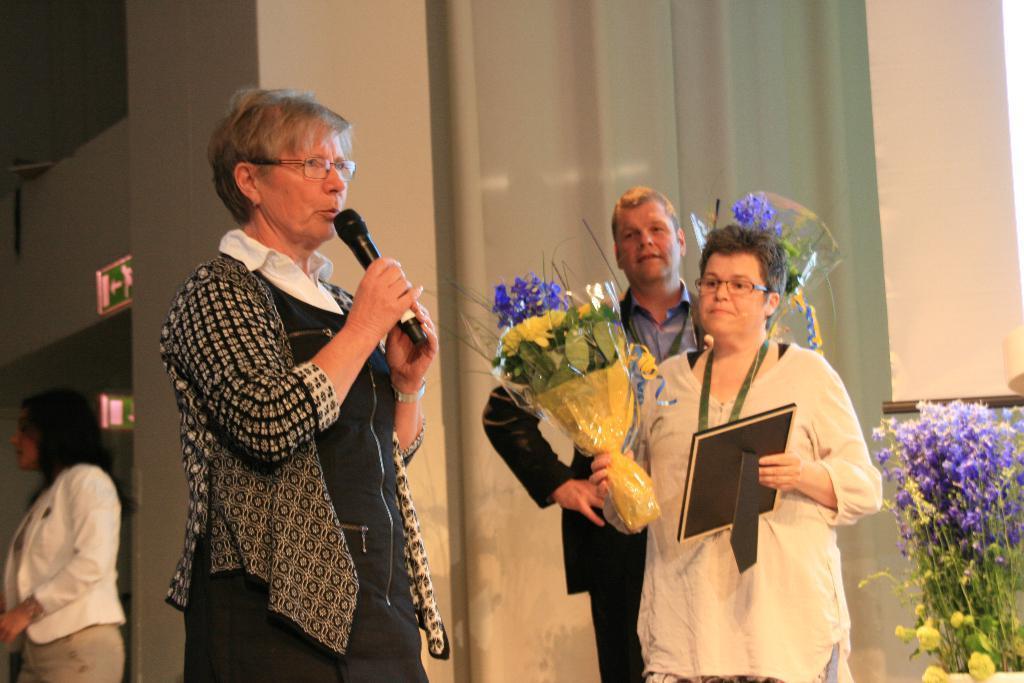Describe this image in one or two sentences. There are four people. They are standing. in the center we have a person. She is holding a mic. On the right side we have a two persons. They are holding a flower bouquet and photo frame. 